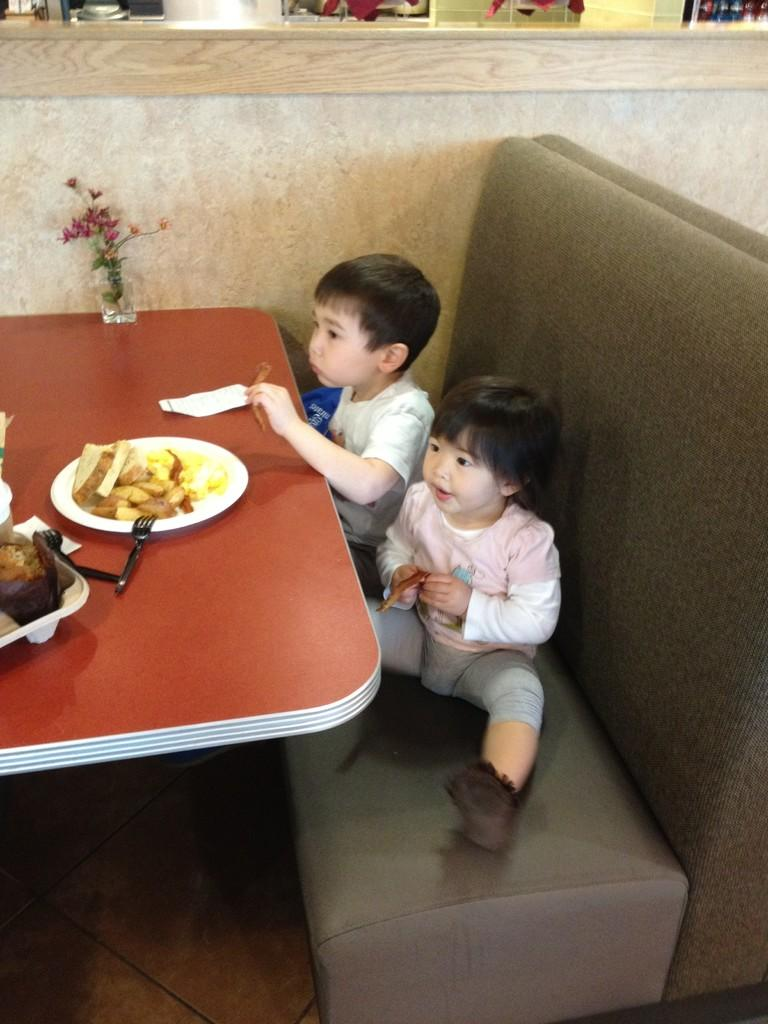How many children are in the image? There are two children in the image. Where are the children sitting? The children are sitting on a sofa. What can be seen in the image besides the children? There is a fork, food on a plate, a plant in a glass, and a table in the image. What color is the table in the image? The table is orange in color. What patch is the children using to read in the image? There is no patch or reading activity depicted in the image. 